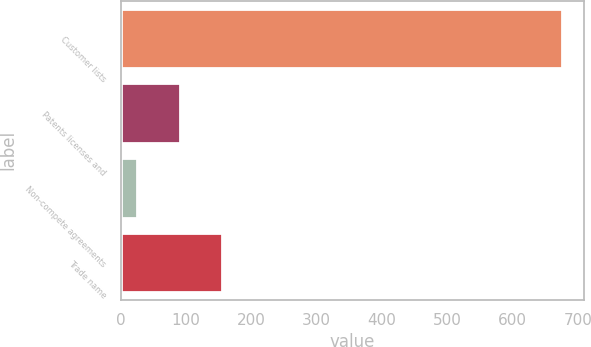Convert chart to OTSL. <chart><loc_0><loc_0><loc_500><loc_500><bar_chart><fcel>Customer lists<fcel>Patents licenses and<fcel>Non-compete agreements<fcel>Trade name<nl><fcel>675.8<fcel>90.62<fcel>25.6<fcel>155.64<nl></chart> 